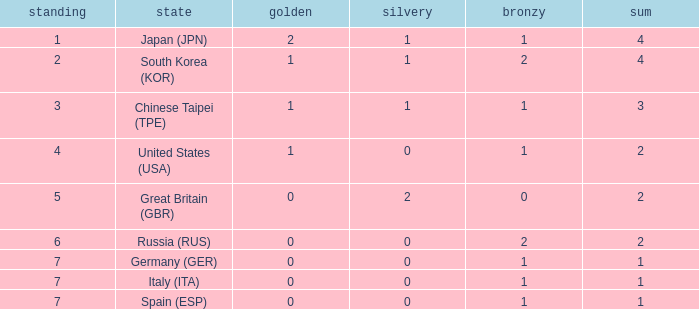I'm looking to parse the entire table for insights. Could you assist me with that? {'header': ['standing', 'state', 'golden', 'silvery', 'bronzy', 'sum'], 'rows': [['1', 'Japan (JPN)', '2', '1', '1', '4'], ['2', 'South Korea (KOR)', '1', '1', '2', '4'], ['3', 'Chinese Taipei (TPE)', '1', '1', '1', '3'], ['4', 'United States (USA)', '1', '0', '1', '2'], ['5', 'Great Britain (GBR)', '0', '2', '0', '2'], ['6', 'Russia (RUS)', '0', '0', '2', '2'], ['7', 'Germany (GER)', '0', '0', '1', '1'], ['7', 'Italy (ITA)', '0', '0', '1', '1'], ['7', 'Spain (ESP)', '0', '0', '1', '1']]} How many total medals does a country with more than 1 silver medals have? 2.0. 